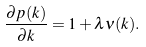<formula> <loc_0><loc_0><loc_500><loc_500>\frac { \partial p ( k ) } { \partial k } = 1 + \lambda \nu ( k ) .</formula> 